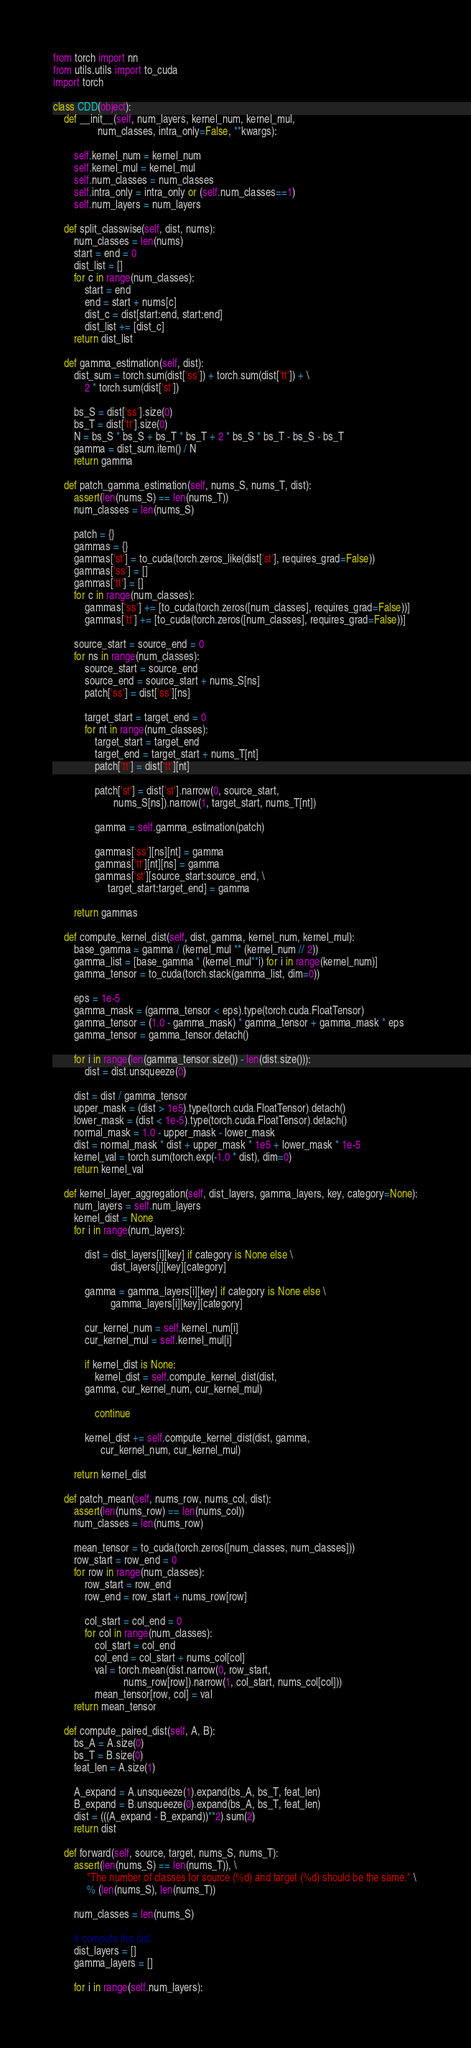Convert code to text. <code><loc_0><loc_0><loc_500><loc_500><_Python_>from torch import nn
from utils.utils import to_cuda
import torch

class CDD(object):
    def __init__(self, num_layers, kernel_num, kernel_mul, 
                 num_classes, intra_only=False, **kwargs):

        self.kernel_num = kernel_num
        self.kernel_mul = kernel_mul
        self.num_classes = num_classes
        self.intra_only = intra_only or (self.num_classes==1)
        self.num_layers = num_layers
    
    def split_classwise(self, dist, nums):
        num_classes = len(nums)
        start = end = 0
        dist_list = []
        for c in range(num_classes):
            start = end
            end = start + nums[c]
            dist_c = dist[start:end, start:end]
            dist_list += [dist_c]
        return dist_list

    def gamma_estimation(self, dist):
        dist_sum = torch.sum(dist['ss']) + torch.sum(dist['tt']) + \
	    	2 * torch.sum(dist['st'])

        bs_S = dist['ss'].size(0)
        bs_T = dist['tt'].size(0)
        N = bs_S * bs_S + bs_T * bs_T + 2 * bs_S * bs_T - bs_S - bs_T
        gamma = dist_sum.item() / N 
        return gamma

    def patch_gamma_estimation(self, nums_S, nums_T, dist):
        assert(len(nums_S) == len(nums_T))
        num_classes = len(nums_S)

        patch = {}
        gammas = {}
        gammas['st'] = to_cuda(torch.zeros_like(dist['st'], requires_grad=False))
        gammas['ss'] = [] 
        gammas['tt'] = [] 
        for c in range(num_classes):
            gammas['ss'] += [to_cuda(torch.zeros([num_classes], requires_grad=False))]
            gammas['tt'] += [to_cuda(torch.zeros([num_classes], requires_grad=False))]

        source_start = source_end = 0
        for ns in range(num_classes):
            source_start = source_end
            source_end = source_start + nums_S[ns]
            patch['ss'] = dist['ss'][ns]

            target_start = target_end = 0
            for nt in range(num_classes):
                target_start = target_end 
                target_end = target_start + nums_T[nt] 
                patch['tt'] = dist['tt'][nt]

                patch['st'] = dist['st'].narrow(0, source_start, 
                       nums_S[ns]).narrow(1, target_start, nums_T[nt]) 

                gamma = self.gamma_estimation(patch)

                gammas['ss'][ns][nt] = gamma
                gammas['tt'][nt][ns] = gamma
                gammas['st'][source_start:source_end, \
                     target_start:target_end] = gamma

        return gammas

    def compute_kernel_dist(self, dist, gamma, kernel_num, kernel_mul):
        base_gamma = gamma / (kernel_mul ** (kernel_num // 2))
        gamma_list = [base_gamma * (kernel_mul**i) for i in range(kernel_num)]
        gamma_tensor = to_cuda(torch.stack(gamma_list, dim=0))

        eps = 1e-5
        gamma_mask = (gamma_tensor < eps).type(torch.cuda.FloatTensor)
        gamma_tensor = (1.0 - gamma_mask) * gamma_tensor + gamma_mask * eps 
        gamma_tensor = gamma_tensor.detach()

        for i in range(len(gamma_tensor.size()) - len(dist.size())):
            dist = dist.unsqueeze(0)

        dist = dist / gamma_tensor
        upper_mask = (dist > 1e5).type(torch.cuda.FloatTensor).detach()
        lower_mask = (dist < 1e-5).type(torch.cuda.FloatTensor).detach()
        normal_mask = 1.0 - upper_mask - lower_mask
        dist = normal_mask * dist + upper_mask * 1e5 + lower_mask * 1e-5
        kernel_val = torch.sum(torch.exp(-1.0 * dist), dim=0)
        return kernel_val

    def kernel_layer_aggregation(self, dist_layers, gamma_layers, key, category=None):
        num_layers = self.num_layers 
        kernel_dist = None
        for i in range(num_layers):

            dist = dist_layers[i][key] if category is None else \
                      dist_layers[i][key][category]

            gamma = gamma_layers[i][key] if category is None else \
                      gamma_layers[i][key][category]

            cur_kernel_num = self.kernel_num[i]
            cur_kernel_mul = self.kernel_mul[i]

            if kernel_dist is None:
                kernel_dist = self.compute_kernel_dist(dist, 
			gamma, cur_kernel_num, cur_kernel_mul) 

                continue

            kernel_dist += self.compute_kernel_dist(dist, gamma, 
                  cur_kernel_num, cur_kernel_mul) 

        return kernel_dist

    def patch_mean(self, nums_row, nums_col, dist):
        assert(len(nums_row) == len(nums_col))
        num_classes = len(nums_row)

        mean_tensor = to_cuda(torch.zeros([num_classes, num_classes]))
        row_start = row_end = 0
        for row in range(num_classes):
            row_start = row_end
            row_end = row_start + nums_row[row]

            col_start = col_end = 0
            for col in range(num_classes):
                col_start = col_end
                col_end = col_start + nums_col[col]
                val = torch.mean(dist.narrow(0, row_start, 
                           nums_row[row]).narrow(1, col_start, nums_col[col]))
                mean_tensor[row, col] = val
        return mean_tensor
        
    def compute_paired_dist(self, A, B):
        bs_A = A.size(0)
        bs_T = B.size(0)
        feat_len = A.size(1)

        A_expand = A.unsqueeze(1).expand(bs_A, bs_T, feat_len)
        B_expand = B.unsqueeze(0).expand(bs_A, bs_T, feat_len)
        dist = (((A_expand - B_expand))**2).sum(2)
        return dist

    def forward(self, source, target, nums_S, nums_T):
        assert(len(nums_S) == len(nums_T)), \
             "The number of classes for source (%d) and target (%d) should be the same." \
             % (len(nums_S), len(nums_T))

        num_classes = len(nums_S)

        # compute the dist 
        dist_layers = []
        gamma_layers = []

        for i in range(self.num_layers):
</code> 